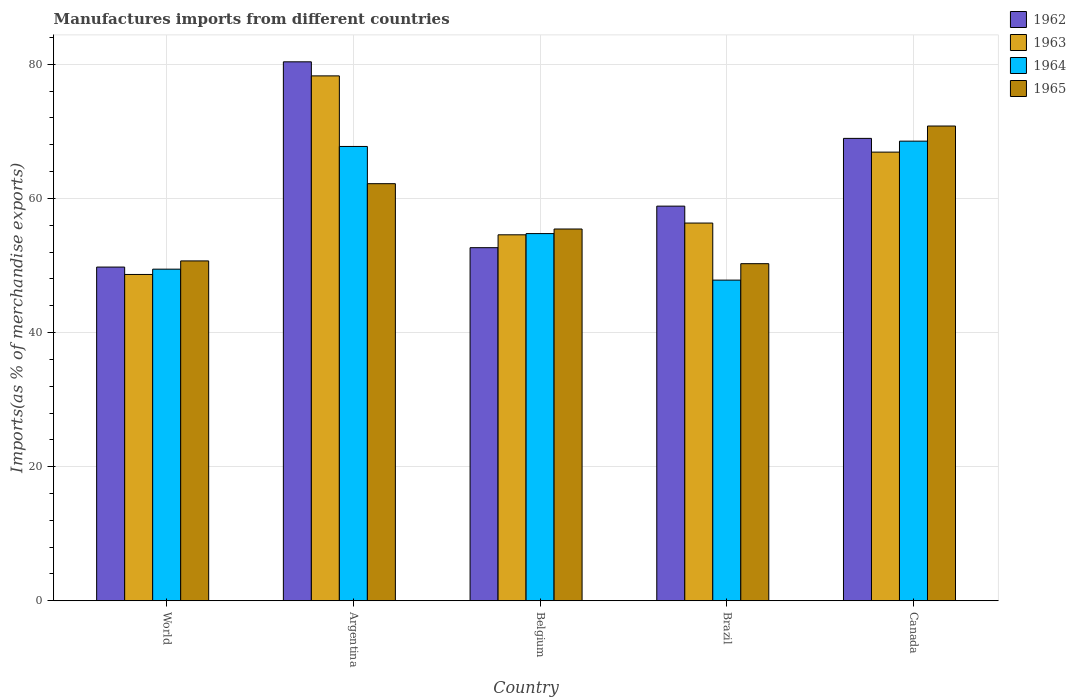Are the number of bars on each tick of the X-axis equal?
Your answer should be very brief. Yes. How many bars are there on the 3rd tick from the right?
Ensure brevity in your answer.  4. In how many cases, is the number of bars for a given country not equal to the number of legend labels?
Your answer should be very brief. 0. What is the percentage of imports to different countries in 1964 in Canada?
Provide a short and direct response. 68.54. Across all countries, what is the maximum percentage of imports to different countries in 1965?
Keep it short and to the point. 70.79. Across all countries, what is the minimum percentage of imports to different countries in 1963?
Offer a very short reply. 48.66. In which country was the percentage of imports to different countries in 1962 maximum?
Make the answer very short. Argentina. What is the total percentage of imports to different countries in 1964 in the graph?
Offer a very short reply. 288.3. What is the difference between the percentage of imports to different countries in 1962 in Argentina and that in World?
Provide a succinct answer. 30.61. What is the difference between the percentage of imports to different countries in 1962 in Argentina and the percentage of imports to different countries in 1965 in Belgium?
Offer a terse response. 24.93. What is the average percentage of imports to different countries in 1962 per country?
Your answer should be compact. 62.12. What is the difference between the percentage of imports to different countries of/in 1965 and percentage of imports to different countries of/in 1963 in Brazil?
Keep it short and to the point. -6.06. What is the ratio of the percentage of imports to different countries in 1963 in Argentina to that in Belgium?
Offer a terse response. 1.43. Is the percentage of imports to different countries in 1962 in Brazil less than that in World?
Make the answer very short. No. Is the difference between the percentage of imports to different countries in 1965 in Argentina and Brazil greater than the difference between the percentage of imports to different countries in 1963 in Argentina and Brazil?
Your answer should be compact. No. What is the difference between the highest and the second highest percentage of imports to different countries in 1962?
Ensure brevity in your answer.  21.52. What is the difference between the highest and the lowest percentage of imports to different countries in 1963?
Your answer should be very brief. 29.61. In how many countries, is the percentage of imports to different countries in 1962 greater than the average percentage of imports to different countries in 1962 taken over all countries?
Provide a short and direct response. 2. Is the sum of the percentage of imports to different countries in 1962 in Argentina and World greater than the maximum percentage of imports to different countries in 1965 across all countries?
Your response must be concise. Yes. Is it the case that in every country, the sum of the percentage of imports to different countries in 1963 and percentage of imports to different countries in 1965 is greater than the sum of percentage of imports to different countries in 1964 and percentage of imports to different countries in 1962?
Offer a very short reply. No. What does the 2nd bar from the left in World represents?
Provide a short and direct response. 1963. What does the 1st bar from the right in Canada represents?
Offer a terse response. 1965. Does the graph contain any zero values?
Your answer should be compact. No. Where does the legend appear in the graph?
Offer a very short reply. Top right. What is the title of the graph?
Your answer should be compact. Manufactures imports from different countries. Does "1966" appear as one of the legend labels in the graph?
Make the answer very short. No. What is the label or title of the X-axis?
Give a very brief answer. Country. What is the label or title of the Y-axis?
Offer a very short reply. Imports(as % of merchandise exports). What is the Imports(as % of merchandise exports) of 1962 in World?
Make the answer very short. 49.76. What is the Imports(as % of merchandise exports) of 1963 in World?
Keep it short and to the point. 48.66. What is the Imports(as % of merchandise exports) of 1964 in World?
Keep it short and to the point. 49.45. What is the Imports(as % of merchandise exports) of 1965 in World?
Your answer should be very brief. 50.68. What is the Imports(as % of merchandise exports) of 1962 in Argentina?
Make the answer very short. 80.37. What is the Imports(as % of merchandise exports) in 1963 in Argentina?
Give a very brief answer. 78.27. What is the Imports(as % of merchandise exports) of 1964 in Argentina?
Keep it short and to the point. 67.75. What is the Imports(as % of merchandise exports) of 1965 in Argentina?
Provide a succinct answer. 62.19. What is the Imports(as % of merchandise exports) in 1962 in Belgium?
Give a very brief answer. 52.65. What is the Imports(as % of merchandise exports) in 1963 in Belgium?
Ensure brevity in your answer.  54.57. What is the Imports(as % of merchandise exports) in 1964 in Belgium?
Your response must be concise. 54.75. What is the Imports(as % of merchandise exports) of 1965 in Belgium?
Your answer should be very brief. 55.44. What is the Imports(as % of merchandise exports) of 1962 in Brazil?
Make the answer very short. 58.85. What is the Imports(as % of merchandise exports) in 1963 in Brazil?
Your answer should be compact. 56.32. What is the Imports(as % of merchandise exports) in 1964 in Brazil?
Give a very brief answer. 47.82. What is the Imports(as % of merchandise exports) of 1965 in Brazil?
Ensure brevity in your answer.  50.27. What is the Imports(as % of merchandise exports) of 1962 in Canada?
Keep it short and to the point. 68.95. What is the Imports(as % of merchandise exports) in 1963 in Canada?
Provide a succinct answer. 66.9. What is the Imports(as % of merchandise exports) in 1964 in Canada?
Your answer should be compact. 68.54. What is the Imports(as % of merchandise exports) in 1965 in Canada?
Ensure brevity in your answer.  70.79. Across all countries, what is the maximum Imports(as % of merchandise exports) in 1962?
Offer a very short reply. 80.37. Across all countries, what is the maximum Imports(as % of merchandise exports) in 1963?
Ensure brevity in your answer.  78.27. Across all countries, what is the maximum Imports(as % of merchandise exports) of 1964?
Ensure brevity in your answer.  68.54. Across all countries, what is the maximum Imports(as % of merchandise exports) in 1965?
Your response must be concise. 70.79. Across all countries, what is the minimum Imports(as % of merchandise exports) in 1962?
Provide a short and direct response. 49.76. Across all countries, what is the minimum Imports(as % of merchandise exports) in 1963?
Provide a succinct answer. 48.66. Across all countries, what is the minimum Imports(as % of merchandise exports) in 1964?
Give a very brief answer. 47.82. Across all countries, what is the minimum Imports(as % of merchandise exports) of 1965?
Offer a very short reply. 50.27. What is the total Imports(as % of merchandise exports) in 1962 in the graph?
Your answer should be very brief. 310.58. What is the total Imports(as % of merchandise exports) in 1963 in the graph?
Offer a terse response. 304.73. What is the total Imports(as % of merchandise exports) of 1964 in the graph?
Your answer should be compact. 288.3. What is the total Imports(as % of merchandise exports) in 1965 in the graph?
Your response must be concise. 289.37. What is the difference between the Imports(as % of merchandise exports) in 1962 in World and that in Argentina?
Give a very brief answer. -30.61. What is the difference between the Imports(as % of merchandise exports) of 1963 in World and that in Argentina?
Ensure brevity in your answer.  -29.61. What is the difference between the Imports(as % of merchandise exports) in 1964 in World and that in Argentina?
Offer a very short reply. -18.3. What is the difference between the Imports(as % of merchandise exports) of 1965 in World and that in Argentina?
Your response must be concise. -11.52. What is the difference between the Imports(as % of merchandise exports) in 1962 in World and that in Belgium?
Ensure brevity in your answer.  -2.89. What is the difference between the Imports(as % of merchandise exports) of 1963 in World and that in Belgium?
Keep it short and to the point. -5.91. What is the difference between the Imports(as % of merchandise exports) of 1964 in World and that in Belgium?
Give a very brief answer. -5.31. What is the difference between the Imports(as % of merchandise exports) in 1965 in World and that in Belgium?
Your answer should be very brief. -4.76. What is the difference between the Imports(as % of merchandise exports) of 1962 in World and that in Brazil?
Provide a succinct answer. -9.09. What is the difference between the Imports(as % of merchandise exports) in 1963 in World and that in Brazil?
Your answer should be compact. -7.66. What is the difference between the Imports(as % of merchandise exports) in 1964 in World and that in Brazil?
Ensure brevity in your answer.  1.63. What is the difference between the Imports(as % of merchandise exports) in 1965 in World and that in Brazil?
Your response must be concise. 0.41. What is the difference between the Imports(as % of merchandise exports) of 1962 in World and that in Canada?
Give a very brief answer. -19.19. What is the difference between the Imports(as % of merchandise exports) of 1963 in World and that in Canada?
Your answer should be compact. -18.24. What is the difference between the Imports(as % of merchandise exports) in 1964 in World and that in Canada?
Ensure brevity in your answer.  -19.09. What is the difference between the Imports(as % of merchandise exports) in 1965 in World and that in Canada?
Give a very brief answer. -20.11. What is the difference between the Imports(as % of merchandise exports) of 1962 in Argentina and that in Belgium?
Your answer should be compact. 27.71. What is the difference between the Imports(as % of merchandise exports) of 1963 in Argentina and that in Belgium?
Make the answer very short. 23.7. What is the difference between the Imports(as % of merchandise exports) in 1964 in Argentina and that in Belgium?
Give a very brief answer. 12.99. What is the difference between the Imports(as % of merchandise exports) in 1965 in Argentina and that in Belgium?
Offer a terse response. 6.76. What is the difference between the Imports(as % of merchandise exports) in 1962 in Argentina and that in Brazil?
Keep it short and to the point. 21.52. What is the difference between the Imports(as % of merchandise exports) in 1963 in Argentina and that in Brazil?
Your response must be concise. 21.95. What is the difference between the Imports(as % of merchandise exports) in 1964 in Argentina and that in Brazil?
Your answer should be compact. 19.93. What is the difference between the Imports(as % of merchandise exports) in 1965 in Argentina and that in Brazil?
Your answer should be compact. 11.93. What is the difference between the Imports(as % of merchandise exports) of 1962 in Argentina and that in Canada?
Provide a short and direct response. 11.42. What is the difference between the Imports(as % of merchandise exports) of 1963 in Argentina and that in Canada?
Keep it short and to the point. 11.37. What is the difference between the Imports(as % of merchandise exports) of 1964 in Argentina and that in Canada?
Provide a short and direct response. -0.79. What is the difference between the Imports(as % of merchandise exports) in 1965 in Argentina and that in Canada?
Provide a short and direct response. -8.6. What is the difference between the Imports(as % of merchandise exports) of 1962 in Belgium and that in Brazil?
Keep it short and to the point. -6.19. What is the difference between the Imports(as % of merchandise exports) of 1963 in Belgium and that in Brazil?
Provide a short and direct response. -1.75. What is the difference between the Imports(as % of merchandise exports) of 1964 in Belgium and that in Brazil?
Your answer should be very brief. 6.94. What is the difference between the Imports(as % of merchandise exports) of 1965 in Belgium and that in Brazil?
Provide a short and direct response. 5.17. What is the difference between the Imports(as % of merchandise exports) of 1962 in Belgium and that in Canada?
Provide a succinct answer. -16.3. What is the difference between the Imports(as % of merchandise exports) of 1963 in Belgium and that in Canada?
Provide a succinct answer. -12.33. What is the difference between the Imports(as % of merchandise exports) in 1964 in Belgium and that in Canada?
Offer a very short reply. -13.78. What is the difference between the Imports(as % of merchandise exports) in 1965 in Belgium and that in Canada?
Ensure brevity in your answer.  -15.36. What is the difference between the Imports(as % of merchandise exports) of 1962 in Brazil and that in Canada?
Your answer should be very brief. -10.1. What is the difference between the Imports(as % of merchandise exports) in 1963 in Brazil and that in Canada?
Keep it short and to the point. -10.58. What is the difference between the Imports(as % of merchandise exports) of 1964 in Brazil and that in Canada?
Give a very brief answer. -20.72. What is the difference between the Imports(as % of merchandise exports) in 1965 in Brazil and that in Canada?
Your response must be concise. -20.53. What is the difference between the Imports(as % of merchandise exports) in 1962 in World and the Imports(as % of merchandise exports) in 1963 in Argentina?
Make the answer very short. -28.51. What is the difference between the Imports(as % of merchandise exports) in 1962 in World and the Imports(as % of merchandise exports) in 1964 in Argentina?
Your response must be concise. -17.98. What is the difference between the Imports(as % of merchandise exports) of 1962 in World and the Imports(as % of merchandise exports) of 1965 in Argentina?
Provide a short and direct response. -12.43. What is the difference between the Imports(as % of merchandise exports) of 1963 in World and the Imports(as % of merchandise exports) of 1964 in Argentina?
Your answer should be very brief. -19.09. What is the difference between the Imports(as % of merchandise exports) in 1963 in World and the Imports(as % of merchandise exports) in 1965 in Argentina?
Give a very brief answer. -13.54. What is the difference between the Imports(as % of merchandise exports) in 1964 in World and the Imports(as % of merchandise exports) in 1965 in Argentina?
Offer a very short reply. -12.75. What is the difference between the Imports(as % of merchandise exports) of 1962 in World and the Imports(as % of merchandise exports) of 1963 in Belgium?
Give a very brief answer. -4.81. What is the difference between the Imports(as % of merchandise exports) of 1962 in World and the Imports(as % of merchandise exports) of 1964 in Belgium?
Make the answer very short. -4.99. What is the difference between the Imports(as % of merchandise exports) in 1962 in World and the Imports(as % of merchandise exports) in 1965 in Belgium?
Make the answer very short. -5.67. What is the difference between the Imports(as % of merchandise exports) of 1963 in World and the Imports(as % of merchandise exports) of 1964 in Belgium?
Provide a succinct answer. -6.09. What is the difference between the Imports(as % of merchandise exports) in 1963 in World and the Imports(as % of merchandise exports) in 1965 in Belgium?
Make the answer very short. -6.78. What is the difference between the Imports(as % of merchandise exports) in 1964 in World and the Imports(as % of merchandise exports) in 1965 in Belgium?
Ensure brevity in your answer.  -5.99. What is the difference between the Imports(as % of merchandise exports) of 1962 in World and the Imports(as % of merchandise exports) of 1963 in Brazil?
Your response must be concise. -6.56. What is the difference between the Imports(as % of merchandise exports) in 1962 in World and the Imports(as % of merchandise exports) in 1964 in Brazil?
Ensure brevity in your answer.  1.95. What is the difference between the Imports(as % of merchandise exports) in 1962 in World and the Imports(as % of merchandise exports) in 1965 in Brazil?
Make the answer very short. -0.51. What is the difference between the Imports(as % of merchandise exports) of 1963 in World and the Imports(as % of merchandise exports) of 1964 in Brazil?
Offer a very short reply. 0.84. What is the difference between the Imports(as % of merchandise exports) of 1963 in World and the Imports(as % of merchandise exports) of 1965 in Brazil?
Your response must be concise. -1.61. What is the difference between the Imports(as % of merchandise exports) of 1964 in World and the Imports(as % of merchandise exports) of 1965 in Brazil?
Make the answer very short. -0.82. What is the difference between the Imports(as % of merchandise exports) of 1962 in World and the Imports(as % of merchandise exports) of 1963 in Canada?
Make the answer very short. -17.14. What is the difference between the Imports(as % of merchandise exports) in 1962 in World and the Imports(as % of merchandise exports) in 1964 in Canada?
Your response must be concise. -18.78. What is the difference between the Imports(as % of merchandise exports) in 1962 in World and the Imports(as % of merchandise exports) in 1965 in Canada?
Provide a short and direct response. -21.03. What is the difference between the Imports(as % of merchandise exports) of 1963 in World and the Imports(as % of merchandise exports) of 1964 in Canada?
Your answer should be very brief. -19.88. What is the difference between the Imports(as % of merchandise exports) in 1963 in World and the Imports(as % of merchandise exports) in 1965 in Canada?
Your response must be concise. -22.13. What is the difference between the Imports(as % of merchandise exports) of 1964 in World and the Imports(as % of merchandise exports) of 1965 in Canada?
Keep it short and to the point. -21.34. What is the difference between the Imports(as % of merchandise exports) of 1962 in Argentina and the Imports(as % of merchandise exports) of 1963 in Belgium?
Your answer should be compact. 25.79. What is the difference between the Imports(as % of merchandise exports) of 1962 in Argentina and the Imports(as % of merchandise exports) of 1964 in Belgium?
Your response must be concise. 25.61. What is the difference between the Imports(as % of merchandise exports) in 1962 in Argentina and the Imports(as % of merchandise exports) in 1965 in Belgium?
Give a very brief answer. 24.93. What is the difference between the Imports(as % of merchandise exports) in 1963 in Argentina and the Imports(as % of merchandise exports) in 1964 in Belgium?
Your answer should be very brief. 23.52. What is the difference between the Imports(as % of merchandise exports) of 1963 in Argentina and the Imports(as % of merchandise exports) of 1965 in Belgium?
Ensure brevity in your answer.  22.83. What is the difference between the Imports(as % of merchandise exports) in 1964 in Argentina and the Imports(as % of merchandise exports) in 1965 in Belgium?
Give a very brief answer. 12.31. What is the difference between the Imports(as % of merchandise exports) in 1962 in Argentina and the Imports(as % of merchandise exports) in 1963 in Brazil?
Your answer should be compact. 24.04. What is the difference between the Imports(as % of merchandise exports) in 1962 in Argentina and the Imports(as % of merchandise exports) in 1964 in Brazil?
Ensure brevity in your answer.  32.55. What is the difference between the Imports(as % of merchandise exports) of 1962 in Argentina and the Imports(as % of merchandise exports) of 1965 in Brazil?
Make the answer very short. 30.1. What is the difference between the Imports(as % of merchandise exports) of 1963 in Argentina and the Imports(as % of merchandise exports) of 1964 in Brazil?
Make the answer very short. 30.45. What is the difference between the Imports(as % of merchandise exports) of 1963 in Argentina and the Imports(as % of merchandise exports) of 1965 in Brazil?
Give a very brief answer. 28. What is the difference between the Imports(as % of merchandise exports) of 1964 in Argentina and the Imports(as % of merchandise exports) of 1965 in Brazil?
Keep it short and to the point. 17.48. What is the difference between the Imports(as % of merchandise exports) in 1962 in Argentina and the Imports(as % of merchandise exports) in 1963 in Canada?
Your response must be concise. 13.46. What is the difference between the Imports(as % of merchandise exports) in 1962 in Argentina and the Imports(as % of merchandise exports) in 1964 in Canada?
Offer a terse response. 11.83. What is the difference between the Imports(as % of merchandise exports) of 1962 in Argentina and the Imports(as % of merchandise exports) of 1965 in Canada?
Your response must be concise. 9.57. What is the difference between the Imports(as % of merchandise exports) of 1963 in Argentina and the Imports(as % of merchandise exports) of 1964 in Canada?
Offer a very short reply. 9.73. What is the difference between the Imports(as % of merchandise exports) in 1963 in Argentina and the Imports(as % of merchandise exports) in 1965 in Canada?
Make the answer very short. 7.48. What is the difference between the Imports(as % of merchandise exports) in 1964 in Argentina and the Imports(as % of merchandise exports) in 1965 in Canada?
Provide a succinct answer. -3.05. What is the difference between the Imports(as % of merchandise exports) of 1962 in Belgium and the Imports(as % of merchandise exports) of 1963 in Brazil?
Your answer should be compact. -3.67. What is the difference between the Imports(as % of merchandise exports) in 1962 in Belgium and the Imports(as % of merchandise exports) in 1964 in Brazil?
Give a very brief answer. 4.84. What is the difference between the Imports(as % of merchandise exports) in 1962 in Belgium and the Imports(as % of merchandise exports) in 1965 in Brazil?
Offer a very short reply. 2.39. What is the difference between the Imports(as % of merchandise exports) in 1963 in Belgium and the Imports(as % of merchandise exports) in 1964 in Brazil?
Give a very brief answer. 6.76. What is the difference between the Imports(as % of merchandise exports) of 1963 in Belgium and the Imports(as % of merchandise exports) of 1965 in Brazil?
Provide a short and direct response. 4.31. What is the difference between the Imports(as % of merchandise exports) in 1964 in Belgium and the Imports(as % of merchandise exports) in 1965 in Brazil?
Offer a very short reply. 4.49. What is the difference between the Imports(as % of merchandise exports) of 1962 in Belgium and the Imports(as % of merchandise exports) of 1963 in Canada?
Offer a very short reply. -14.25. What is the difference between the Imports(as % of merchandise exports) of 1962 in Belgium and the Imports(as % of merchandise exports) of 1964 in Canada?
Provide a short and direct response. -15.88. What is the difference between the Imports(as % of merchandise exports) of 1962 in Belgium and the Imports(as % of merchandise exports) of 1965 in Canada?
Make the answer very short. -18.14. What is the difference between the Imports(as % of merchandise exports) of 1963 in Belgium and the Imports(as % of merchandise exports) of 1964 in Canada?
Make the answer very short. -13.96. What is the difference between the Imports(as % of merchandise exports) in 1963 in Belgium and the Imports(as % of merchandise exports) in 1965 in Canada?
Ensure brevity in your answer.  -16.22. What is the difference between the Imports(as % of merchandise exports) of 1964 in Belgium and the Imports(as % of merchandise exports) of 1965 in Canada?
Provide a short and direct response. -16.04. What is the difference between the Imports(as % of merchandise exports) of 1962 in Brazil and the Imports(as % of merchandise exports) of 1963 in Canada?
Your response must be concise. -8.06. What is the difference between the Imports(as % of merchandise exports) in 1962 in Brazil and the Imports(as % of merchandise exports) in 1964 in Canada?
Offer a terse response. -9.69. What is the difference between the Imports(as % of merchandise exports) of 1962 in Brazil and the Imports(as % of merchandise exports) of 1965 in Canada?
Your answer should be compact. -11.95. What is the difference between the Imports(as % of merchandise exports) in 1963 in Brazil and the Imports(as % of merchandise exports) in 1964 in Canada?
Your response must be concise. -12.21. What is the difference between the Imports(as % of merchandise exports) of 1963 in Brazil and the Imports(as % of merchandise exports) of 1965 in Canada?
Your response must be concise. -14.47. What is the difference between the Imports(as % of merchandise exports) of 1964 in Brazil and the Imports(as % of merchandise exports) of 1965 in Canada?
Provide a short and direct response. -22.98. What is the average Imports(as % of merchandise exports) of 1962 per country?
Your response must be concise. 62.12. What is the average Imports(as % of merchandise exports) in 1963 per country?
Your answer should be very brief. 60.95. What is the average Imports(as % of merchandise exports) in 1964 per country?
Provide a succinct answer. 57.66. What is the average Imports(as % of merchandise exports) of 1965 per country?
Keep it short and to the point. 57.87. What is the difference between the Imports(as % of merchandise exports) of 1962 and Imports(as % of merchandise exports) of 1963 in World?
Ensure brevity in your answer.  1.1. What is the difference between the Imports(as % of merchandise exports) in 1962 and Imports(as % of merchandise exports) in 1964 in World?
Provide a succinct answer. 0.31. What is the difference between the Imports(as % of merchandise exports) of 1962 and Imports(as % of merchandise exports) of 1965 in World?
Offer a terse response. -0.92. What is the difference between the Imports(as % of merchandise exports) in 1963 and Imports(as % of merchandise exports) in 1964 in World?
Give a very brief answer. -0.79. What is the difference between the Imports(as % of merchandise exports) of 1963 and Imports(as % of merchandise exports) of 1965 in World?
Provide a short and direct response. -2.02. What is the difference between the Imports(as % of merchandise exports) in 1964 and Imports(as % of merchandise exports) in 1965 in World?
Provide a short and direct response. -1.23. What is the difference between the Imports(as % of merchandise exports) in 1962 and Imports(as % of merchandise exports) in 1963 in Argentina?
Offer a terse response. 2.1. What is the difference between the Imports(as % of merchandise exports) of 1962 and Imports(as % of merchandise exports) of 1964 in Argentina?
Make the answer very short. 12.62. What is the difference between the Imports(as % of merchandise exports) of 1962 and Imports(as % of merchandise exports) of 1965 in Argentina?
Provide a short and direct response. 18.17. What is the difference between the Imports(as % of merchandise exports) in 1963 and Imports(as % of merchandise exports) in 1964 in Argentina?
Offer a terse response. 10.52. What is the difference between the Imports(as % of merchandise exports) in 1963 and Imports(as % of merchandise exports) in 1965 in Argentina?
Your response must be concise. 16.08. What is the difference between the Imports(as % of merchandise exports) in 1964 and Imports(as % of merchandise exports) in 1965 in Argentina?
Your answer should be compact. 5.55. What is the difference between the Imports(as % of merchandise exports) of 1962 and Imports(as % of merchandise exports) of 1963 in Belgium?
Provide a short and direct response. -1.92. What is the difference between the Imports(as % of merchandise exports) in 1962 and Imports(as % of merchandise exports) in 1964 in Belgium?
Ensure brevity in your answer.  -2.1. What is the difference between the Imports(as % of merchandise exports) in 1962 and Imports(as % of merchandise exports) in 1965 in Belgium?
Your answer should be compact. -2.78. What is the difference between the Imports(as % of merchandise exports) in 1963 and Imports(as % of merchandise exports) in 1964 in Belgium?
Provide a succinct answer. -0.18. What is the difference between the Imports(as % of merchandise exports) in 1963 and Imports(as % of merchandise exports) in 1965 in Belgium?
Your response must be concise. -0.86. What is the difference between the Imports(as % of merchandise exports) in 1964 and Imports(as % of merchandise exports) in 1965 in Belgium?
Provide a succinct answer. -0.68. What is the difference between the Imports(as % of merchandise exports) of 1962 and Imports(as % of merchandise exports) of 1963 in Brazil?
Give a very brief answer. 2.52. What is the difference between the Imports(as % of merchandise exports) of 1962 and Imports(as % of merchandise exports) of 1964 in Brazil?
Your answer should be compact. 11.03. What is the difference between the Imports(as % of merchandise exports) in 1962 and Imports(as % of merchandise exports) in 1965 in Brazil?
Your answer should be compact. 8.58. What is the difference between the Imports(as % of merchandise exports) in 1963 and Imports(as % of merchandise exports) in 1964 in Brazil?
Provide a succinct answer. 8.51. What is the difference between the Imports(as % of merchandise exports) in 1963 and Imports(as % of merchandise exports) in 1965 in Brazil?
Your answer should be very brief. 6.06. What is the difference between the Imports(as % of merchandise exports) in 1964 and Imports(as % of merchandise exports) in 1965 in Brazil?
Offer a very short reply. -2.45. What is the difference between the Imports(as % of merchandise exports) of 1962 and Imports(as % of merchandise exports) of 1963 in Canada?
Your answer should be very brief. 2.05. What is the difference between the Imports(as % of merchandise exports) in 1962 and Imports(as % of merchandise exports) in 1964 in Canada?
Offer a terse response. 0.41. What is the difference between the Imports(as % of merchandise exports) in 1962 and Imports(as % of merchandise exports) in 1965 in Canada?
Provide a short and direct response. -1.84. What is the difference between the Imports(as % of merchandise exports) in 1963 and Imports(as % of merchandise exports) in 1964 in Canada?
Keep it short and to the point. -1.64. What is the difference between the Imports(as % of merchandise exports) in 1963 and Imports(as % of merchandise exports) in 1965 in Canada?
Offer a very short reply. -3.89. What is the difference between the Imports(as % of merchandise exports) in 1964 and Imports(as % of merchandise exports) in 1965 in Canada?
Give a very brief answer. -2.26. What is the ratio of the Imports(as % of merchandise exports) in 1962 in World to that in Argentina?
Your answer should be compact. 0.62. What is the ratio of the Imports(as % of merchandise exports) in 1963 in World to that in Argentina?
Your answer should be very brief. 0.62. What is the ratio of the Imports(as % of merchandise exports) in 1964 in World to that in Argentina?
Your answer should be very brief. 0.73. What is the ratio of the Imports(as % of merchandise exports) of 1965 in World to that in Argentina?
Offer a very short reply. 0.81. What is the ratio of the Imports(as % of merchandise exports) in 1962 in World to that in Belgium?
Provide a succinct answer. 0.95. What is the ratio of the Imports(as % of merchandise exports) in 1963 in World to that in Belgium?
Your answer should be very brief. 0.89. What is the ratio of the Imports(as % of merchandise exports) of 1964 in World to that in Belgium?
Ensure brevity in your answer.  0.9. What is the ratio of the Imports(as % of merchandise exports) of 1965 in World to that in Belgium?
Make the answer very short. 0.91. What is the ratio of the Imports(as % of merchandise exports) of 1962 in World to that in Brazil?
Make the answer very short. 0.85. What is the ratio of the Imports(as % of merchandise exports) in 1963 in World to that in Brazil?
Your answer should be very brief. 0.86. What is the ratio of the Imports(as % of merchandise exports) of 1964 in World to that in Brazil?
Offer a terse response. 1.03. What is the ratio of the Imports(as % of merchandise exports) of 1965 in World to that in Brazil?
Provide a succinct answer. 1.01. What is the ratio of the Imports(as % of merchandise exports) in 1962 in World to that in Canada?
Give a very brief answer. 0.72. What is the ratio of the Imports(as % of merchandise exports) of 1963 in World to that in Canada?
Provide a short and direct response. 0.73. What is the ratio of the Imports(as % of merchandise exports) of 1964 in World to that in Canada?
Offer a terse response. 0.72. What is the ratio of the Imports(as % of merchandise exports) of 1965 in World to that in Canada?
Offer a terse response. 0.72. What is the ratio of the Imports(as % of merchandise exports) in 1962 in Argentina to that in Belgium?
Provide a short and direct response. 1.53. What is the ratio of the Imports(as % of merchandise exports) of 1963 in Argentina to that in Belgium?
Offer a terse response. 1.43. What is the ratio of the Imports(as % of merchandise exports) in 1964 in Argentina to that in Belgium?
Provide a succinct answer. 1.24. What is the ratio of the Imports(as % of merchandise exports) in 1965 in Argentina to that in Belgium?
Keep it short and to the point. 1.12. What is the ratio of the Imports(as % of merchandise exports) of 1962 in Argentina to that in Brazil?
Give a very brief answer. 1.37. What is the ratio of the Imports(as % of merchandise exports) in 1963 in Argentina to that in Brazil?
Provide a short and direct response. 1.39. What is the ratio of the Imports(as % of merchandise exports) of 1964 in Argentina to that in Brazil?
Provide a succinct answer. 1.42. What is the ratio of the Imports(as % of merchandise exports) in 1965 in Argentina to that in Brazil?
Give a very brief answer. 1.24. What is the ratio of the Imports(as % of merchandise exports) in 1962 in Argentina to that in Canada?
Your answer should be compact. 1.17. What is the ratio of the Imports(as % of merchandise exports) of 1963 in Argentina to that in Canada?
Your answer should be very brief. 1.17. What is the ratio of the Imports(as % of merchandise exports) of 1964 in Argentina to that in Canada?
Provide a succinct answer. 0.99. What is the ratio of the Imports(as % of merchandise exports) of 1965 in Argentina to that in Canada?
Your answer should be very brief. 0.88. What is the ratio of the Imports(as % of merchandise exports) of 1962 in Belgium to that in Brazil?
Your answer should be very brief. 0.89. What is the ratio of the Imports(as % of merchandise exports) in 1963 in Belgium to that in Brazil?
Ensure brevity in your answer.  0.97. What is the ratio of the Imports(as % of merchandise exports) of 1964 in Belgium to that in Brazil?
Keep it short and to the point. 1.15. What is the ratio of the Imports(as % of merchandise exports) of 1965 in Belgium to that in Brazil?
Make the answer very short. 1.1. What is the ratio of the Imports(as % of merchandise exports) in 1962 in Belgium to that in Canada?
Provide a succinct answer. 0.76. What is the ratio of the Imports(as % of merchandise exports) of 1963 in Belgium to that in Canada?
Make the answer very short. 0.82. What is the ratio of the Imports(as % of merchandise exports) in 1964 in Belgium to that in Canada?
Provide a succinct answer. 0.8. What is the ratio of the Imports(as % of merchandise exports) of 1965 in Belgium to that in Canada?
Provide a short and direct response. 0.78. What is the ratio of the Imports(as % of merchandise exports) in 1962 in Brazil to that in Canada?
Offer a very short reply. 0.85. What is the ratio of the Imports(as % of merchandise exports) of 1963 in Brazil to that in Canada?
Your response must be concise. 0.84. What is the ratio of the Imports(as % of merchandise exports) of 1964 in Brazil to that in Canada?
Offer a terse response. 0.7. What is the ratio of the Imports(as % of merchandise exports) in 1965 in Brazil to that in Canada?
Provide a succinct answer. 0.71. What is the difference between the highest and the second highest Imports(as % of merchandise exports) in 1962?
Make the answer very short. 11.42. What is the difference between the highest and the second highest Imports(as % of merchandise exports) in 1963?
Ensure brevity in your answer.  11.37. What is the difference between the highest and the second highest Imports(as % of merchandise exports) of 1964?
Ensure brevity in your answer.  0.79. What is the difference between the highest and the second highest Imports(as % of merchandise exports) in 1965?
Provide a succinct answer. 8.6. What is the difference between the highest and the lowest Imports(as % of merchandise exports) of 1962?
Your response must be concise. 30.61. What is the difference between the highest and the lowest Imports(as % of merchandise exports) in 1963?
Offer a terse response. 29.61. What is the difference between the highest and the lowest Imports(as % of merchandise exports) in 1964?
Keep it short and to the point. 20.72. What is the difference between the highest and the lowest Imports(as % of merchandise exports) of 1965?
Your answer should be compact. 20.53. 